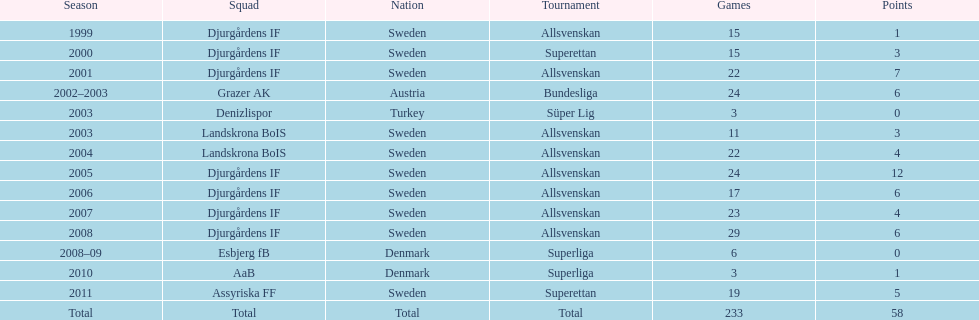How many matches overall were there? 233. Write the full table. {'header': ['Season', 'Squad', 'Nation', 'Tournament', 'Games', 'Points'], 'rows': [['1999', 'Djurgårdens IF', 'Sweden', 'Allsvenskan', '15', '1'], ['2000', 'Djurgårdens IF', 'Sweden', 'Superettan', '15', '3'], ['2001', 'Djurgårdens IF', 'Sweden', 'Allsvenskan', '22', '7'], ['2002–2003', 'Grazer AK', 'Austria', 'Bundesliga', '24', '6'], ['2003', 'Denizlispor', 'Turkey', 'Süper Lig', '3', '0'], ['2003', 'Landskrona BoIS', 'Sweden', 'Allsvenskan', '11', '3'], ['2004', 'Landskrona BoIS', 'Sweden', 'Allsvenskan', '22', '4'], ['2005', 'Djurgårdens IF', 'Sweden', 'Allsvenskan', '24', '12'], ['2006', 'Djurgårdens IF', 'Sweden', 'Allsvenskan', '17', '6'], ['2007', 'Djurgårdens IF', 'Sweden', 'Allsvenskan', '23', '4'], ['2008', 'Djurgårdens IF', 'Sweden', 'Allsvenskan', '29', '6'], ['2008–09', 'Esbjerg fB', 'Denmark', 'Superliga', '6', '0'], ['2010', 'AaB', 'Denmark', 'Superliga', '3', '1'], ['2011', 'Assyriska FF', 'Sweden', 'Superettan', '19', '5'], ['Total', 'Total', 'Total', 'Total', '233', '58']]} 